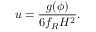Convert formula to latex. <formula><loc_0><loc_0><loc_500><loc_500>u = \frac { g ( \phi ) } { 6 f _ { R } H ^ { 2 } } .</formula> 